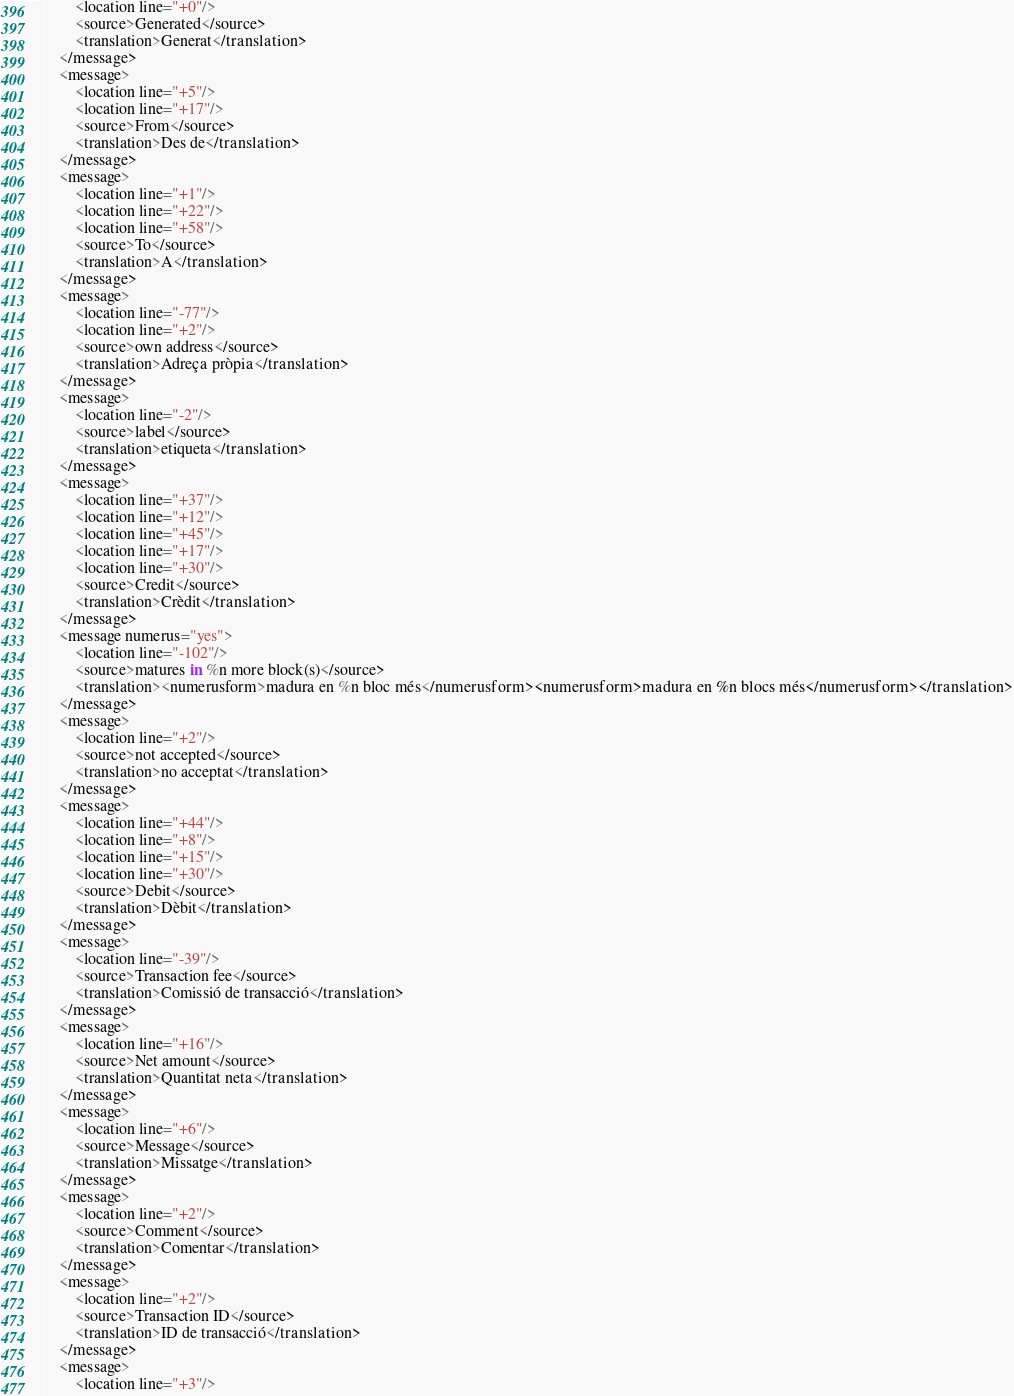<code> <loc_0><loc_0><loc_500><loc_500><_TypeScript_>        <location line="+0"/>
        <source>Generated</source>
        <translation>Generat</translation>
    </message>
    <message>
        <location line="+5"/>
        <location line="+17"/>
        <source>From</source>
        <translation>Des de</translation>
    </message>
    <message>
        <location line="+1"/>
        <location line="+22"/>
        <location line="+58"/>
        <source>To</source>
        <translation>A</translation>
    </message>
    <message>
        <location line="-77"/>
        <location line="+2"/>
        <source>own address</source>
        <translation>Adreça pròpia</translation>
    </message>
    <message>
        <location line="-2"/>
        <source>label</source>
        <translation>etiqueta</translation>
    </message>
    <message>
        <location line="+37"/>
        <location line="+12"/>
        <location line="+45"/>
        <location line="+17"/>
        <location line="+30"/>
        <source>Credit</source>
        <translation>Crèdit</translation>
    </message>
    <message numerus="yes">
        <location line="-102"/>
        <source>matures in %n more block(s)</source>
        <translation><numerusform>madura en %n bloc més</numerusform><numerusform>madura en %n blocs més</numerusform></translation>
    </message>
    <message>
        <location line="+2"/>
        <source>not accepted</source>
        <translation>no acceptat</translation>
    </message>
    <message>
        <location line="+44"/>
        <location line="+8"/>
        <location line="+15"/>
        <location line="+30"/>
        <source>Debit</source>
        <translation>Dèbit</translation>
    </message>
    <message>
        <location line="-39"/>
        <source>Transaction fee</source>
        <translation>Comissió de transacció</translation>
    </message>
    <message>
        <location line="+16"/>
        <source>Net amount</source>
        <translation>Quantitat neta</translation>
    </message>
    <message>
        <location line="+6"/>
        <source>Message</source>
        <translation>Missatge</translation>
    </message>
    <message>
        <location line="+2"/>
        <source>Comment</source>
        <translation>Comentar</translation>
    </message>
    <message>
        <location line="+2"/>
        <source>Transaction ID</source>
        <translation>ID de transacció</translation>
    </message>
    <message>
        <location line="+3"/></code> 